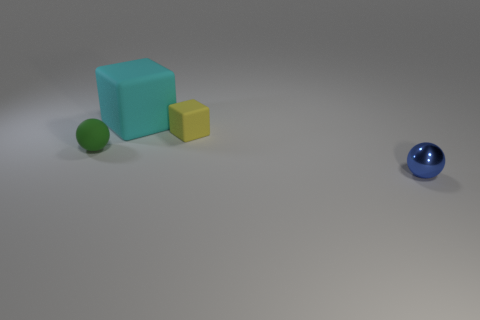Is the color of the metal ball on the right side of the tiny block the same as the sphere left of the small metallic thing?
Keep it short and to the point. No. What number of other rubber spheres are the same size as the green sphere?
Give a very brief answer. 0. Does the ball that is left of the blue ball have the same size as the cyan rubber thing?
Provide a succinct answer. No. There is a big matte thing; what shape is it?
Make the answer very short. Cube. Is the ball that is in front of the tiny green sphere made of the same material as the yellow block?
Provide a short and direct response. No. Are there any matte objects that have the same color as the small matte block?
Your answer should be compact. No. There is a small object that is left of the large cube; is it the same shape as the tiny matte thing on the right side of the tiny green thing?
Provide a succinct answer. No. Is there a cube made of the same material as the small green thing?
Your answer should be very brief. Yes. What number of red things are either balls or small metal spheres?
Provide a succinct answer. 0. There is a thing that is to the right of the cyan object and behind the green object; what is its size?
Provide a short and direct response. Small. 